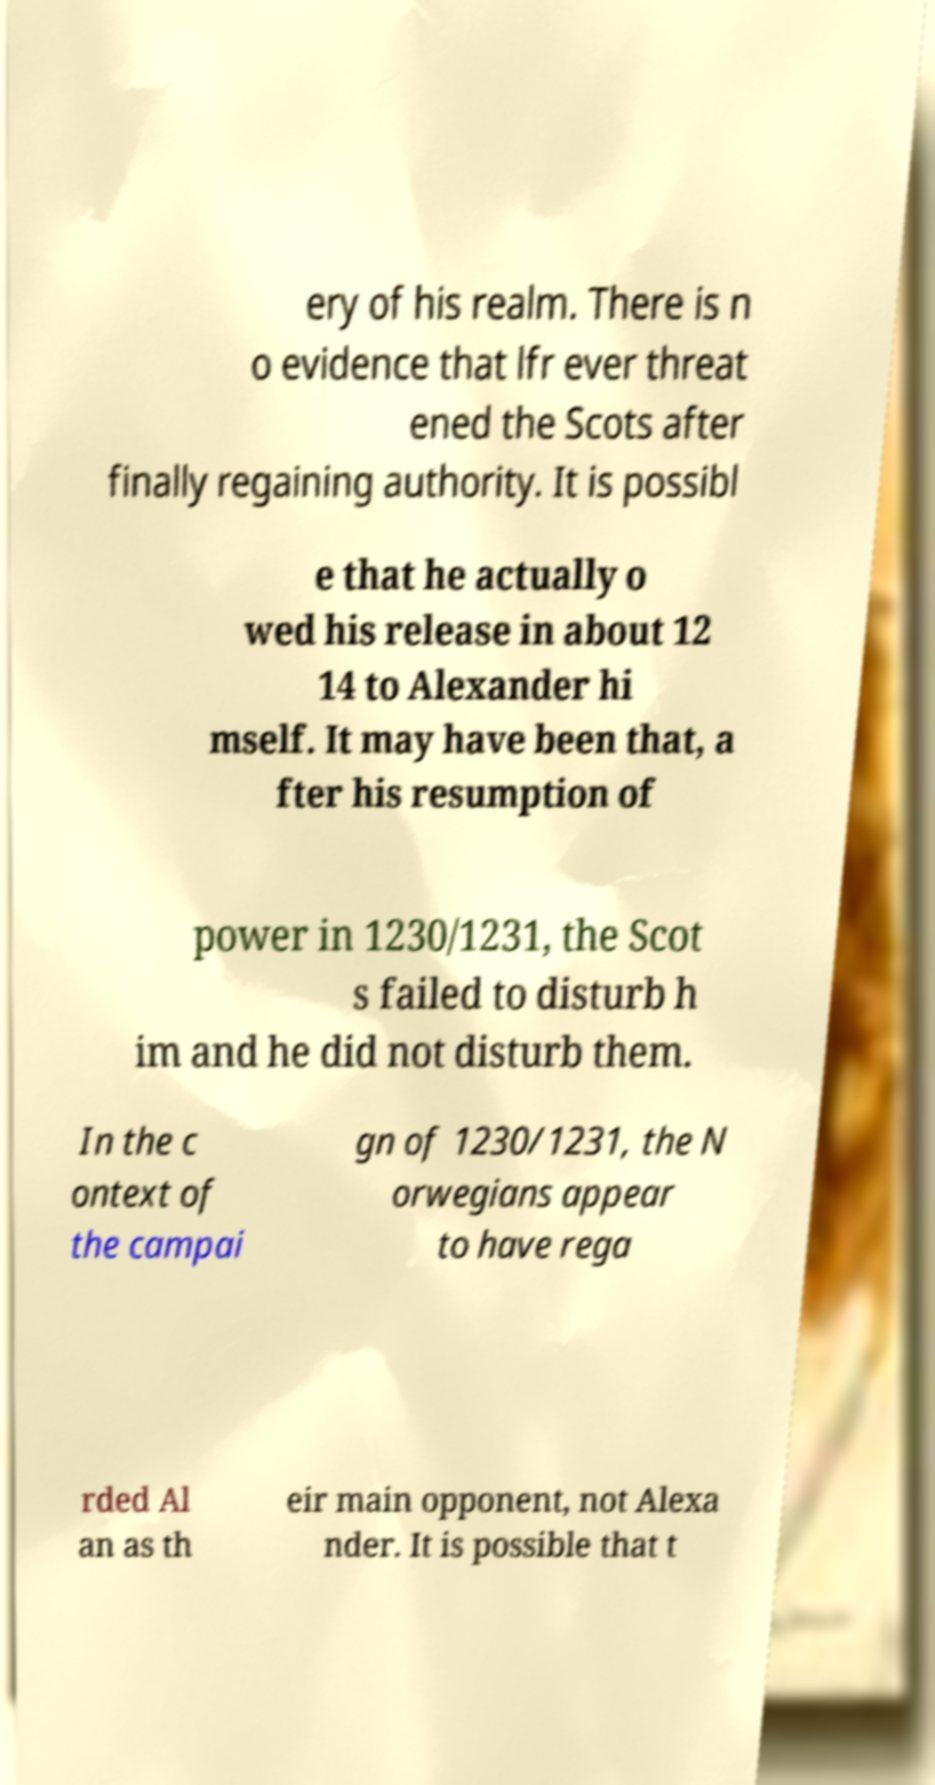There's text embedded in this image that I need extracted. Can you transcribe it verbatim? ery of his realm. There is n o evidence that lfr ever threat ened the Scots after finally regaining authority. It is possibl e that he actually o wed his release in about 12 14 to Alexander hi mself. It may have been that, a fter his resumption of power in 1230/1231, the Scot s failed to disturb h im and he did not disturb them. In the c ontext of the campai gn of 1230/1231, the N orwegians appear to have rega rded Al an as th eir main opponent, not Alexa nder. It is possible that t 